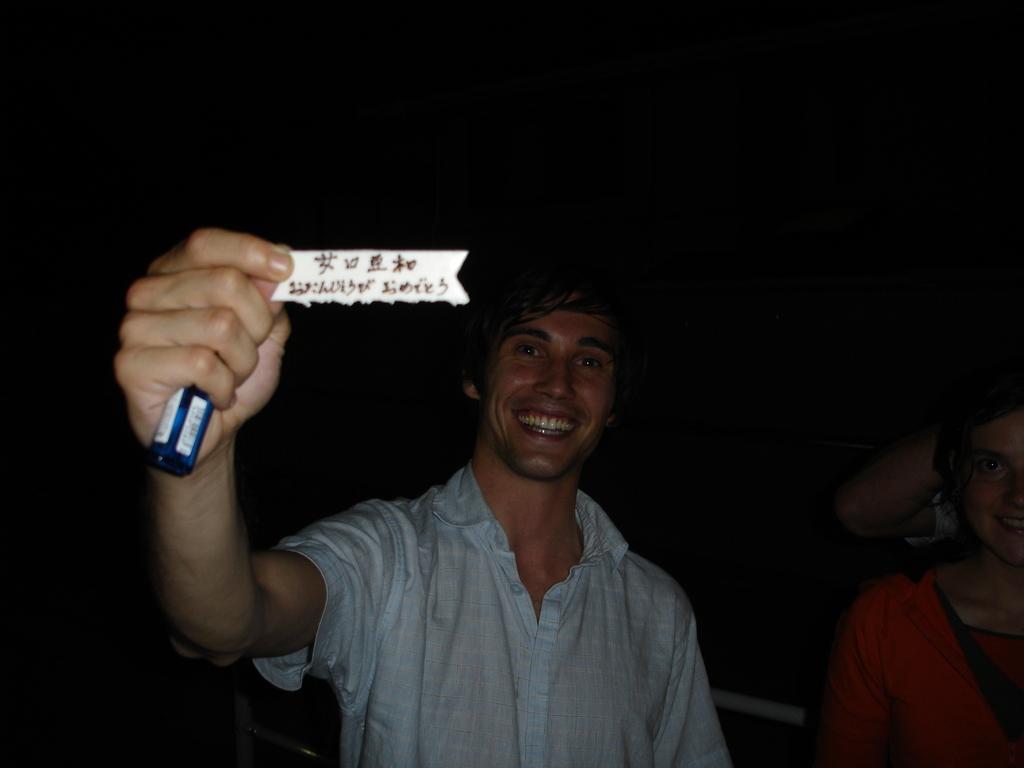Could you give a brief overview of what you see in this image? In the picture I can see a man is holding a paper and an object in the hand. The man is wearing a shirt. On the right side I can see a person. The background of the image is dark. On the paper I can see something written on it. 